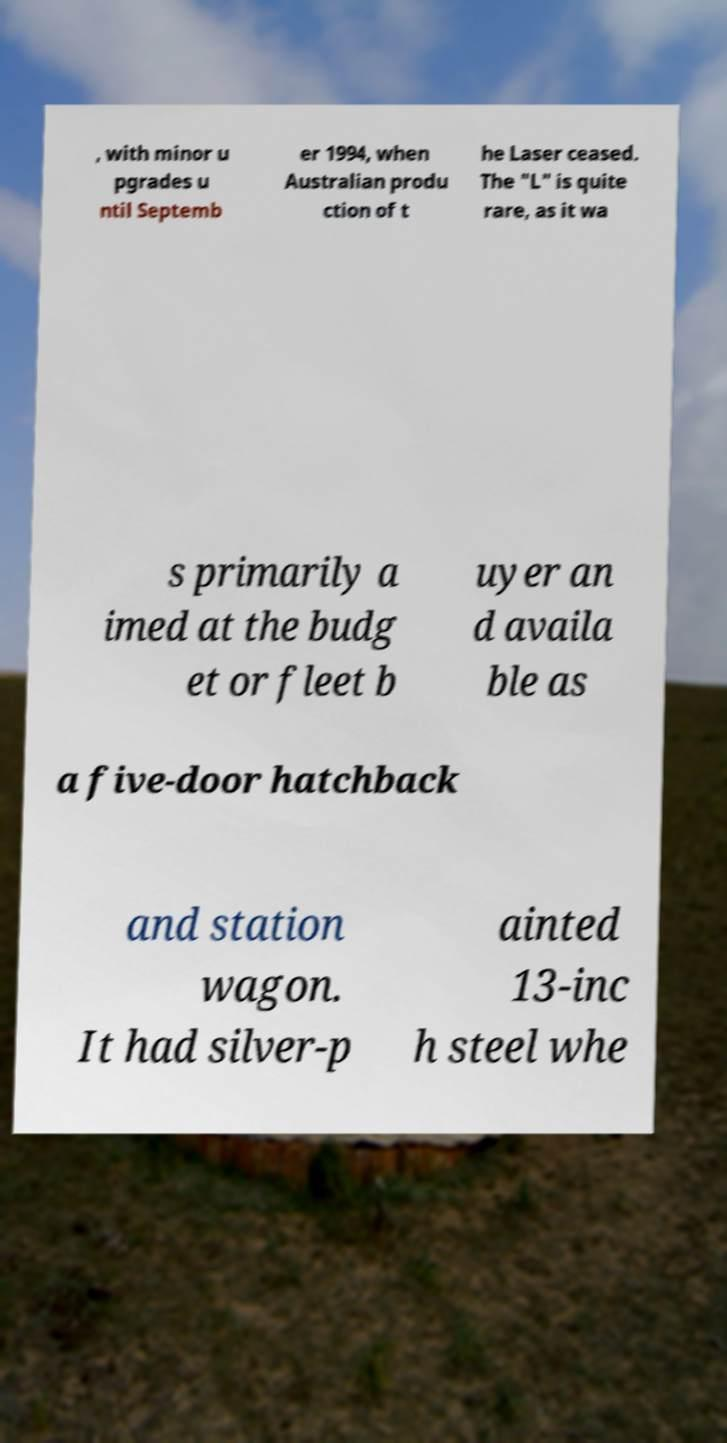Please identify and transcribe the text found in this image. , with minor u pgrades u ntil Septemb er 1994, when Australian produ ction of t he Laser ceased. The "L" is quite rare, as it wa s primarily a imed at the budg et or fleet b uyer an d availa ble as a five-door hatchback and station wagon. It had silver-p ainted 13-inc h steel whe 